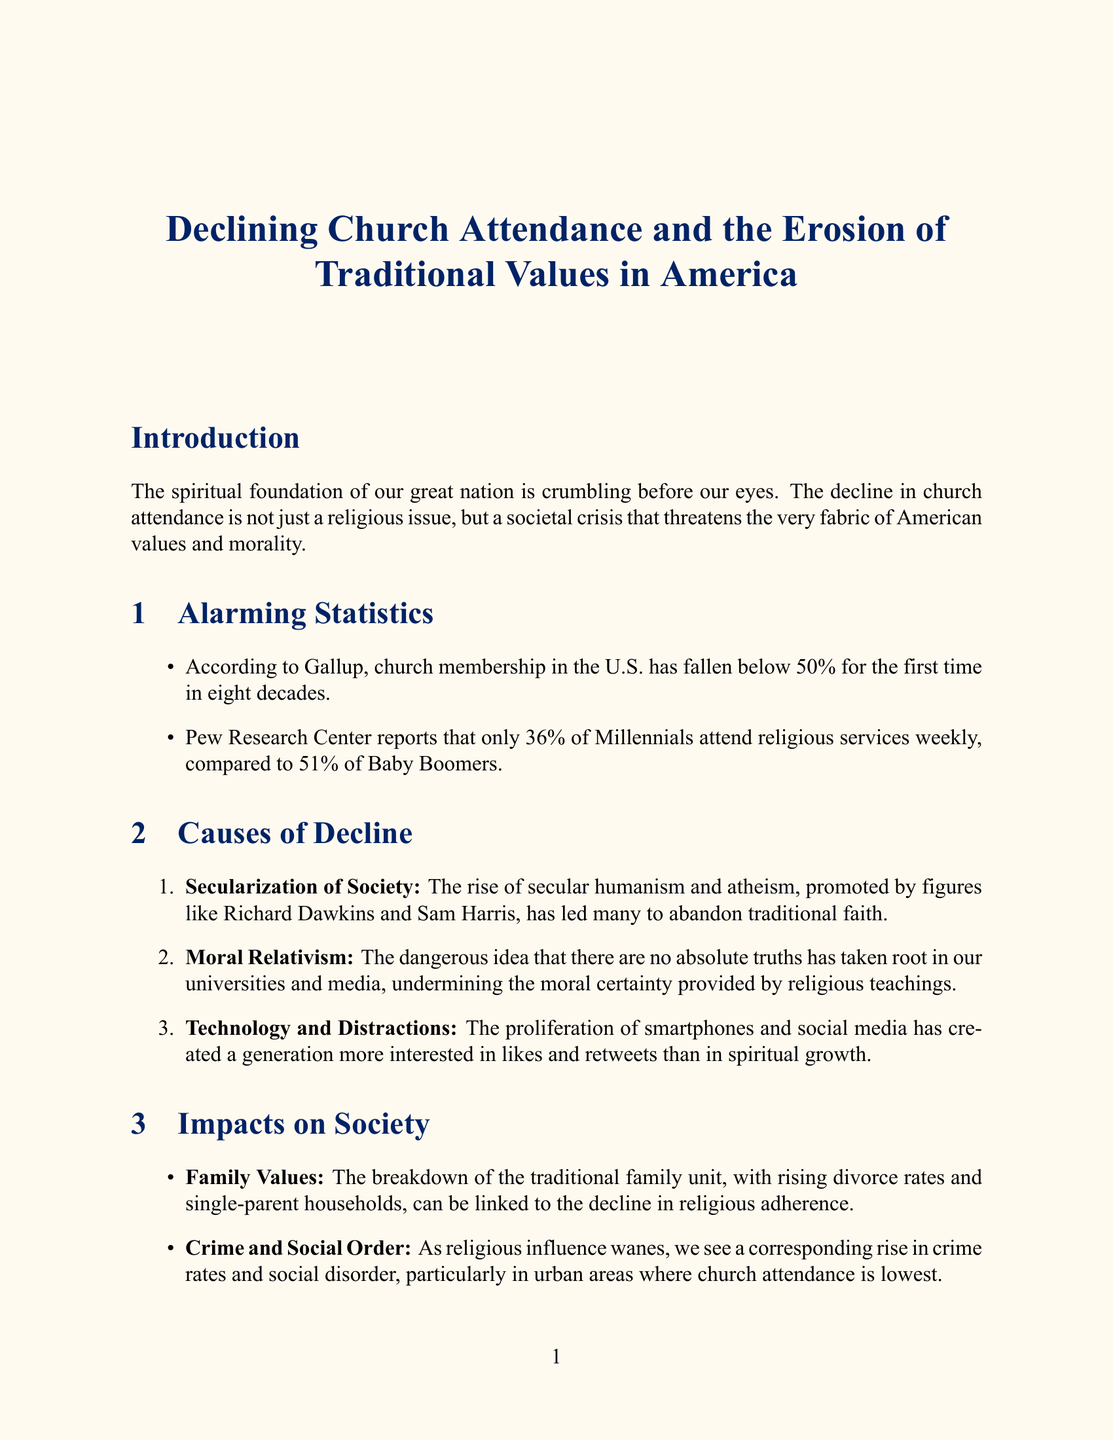What is the overall decline in church membership? The document states that church membership in the U.S. has fallen below 50% for the first time in eight decades.
Answer: Below 50% What percentage of Millennials attend religious services weekly? The document mentions that only 36% of Millennials attend religious services weekly.
Answer: 36% What city has one of the lowest church attendance rates in the country? The document indicates that Portland, Oregon has one of the lowest church attendance rates.
Answer: Portland, Oregon Who is the author of the quote regarding the correlation of church attendance and moral decline? The document cites Dr. Robert Jeffress as the author of the quote about church attendance and moral decline.
Answer: Dr. Robert Jeffress What dangerous idea has taken root in universities and media? The document describes moral relativism as the dangerous idea that there are no absolute truths.
Answer: Moral relativism How does the decline in church attendance impact family values? The document links the breakdown of the traditional family unit to the decline in religious adherence.
Answer: Breakdown of the traditional family unit What does Franklin Graham believe abandoning Judeo-Christian values leads to? The document states that Franklin Graham believes it is a recipe for societal collapse.
Answer: Societal collapse What is the suggested action for Americans regarding church attendance? The document calls for Americans to return to their spiritual roots and attend church regularly.
Answer: Attend church regularly 